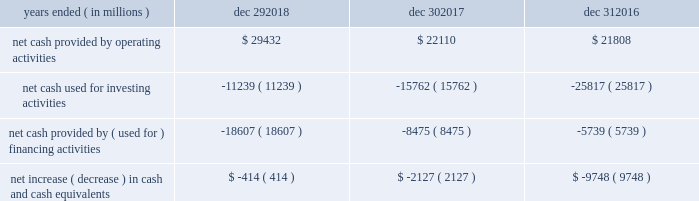Sources and uses of cash ( in millions ) in summary , our cash flows for each period were as follows : years ended ( in millions ) dec 29 , dec 30 , dec 31 .
Md&a consolidated results and analysis 40 .
What was the percentage change in net cash provided by operating activities between 2017 and 2018? 
Computations: ((29432 - 22110) / 22110)
Answer: 0.33116. 